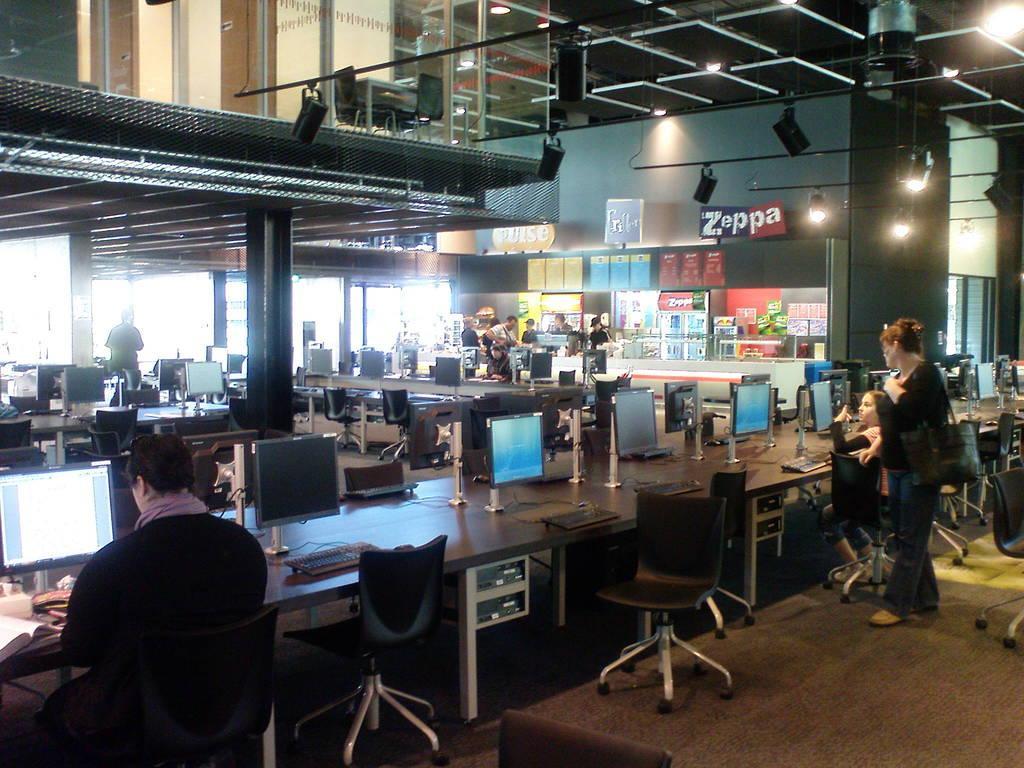In one or two sentences, can you explain what this image depicts? As we can see in the image there are chairs, tables and on tables there are few laptops and there are few people standing here and there. 